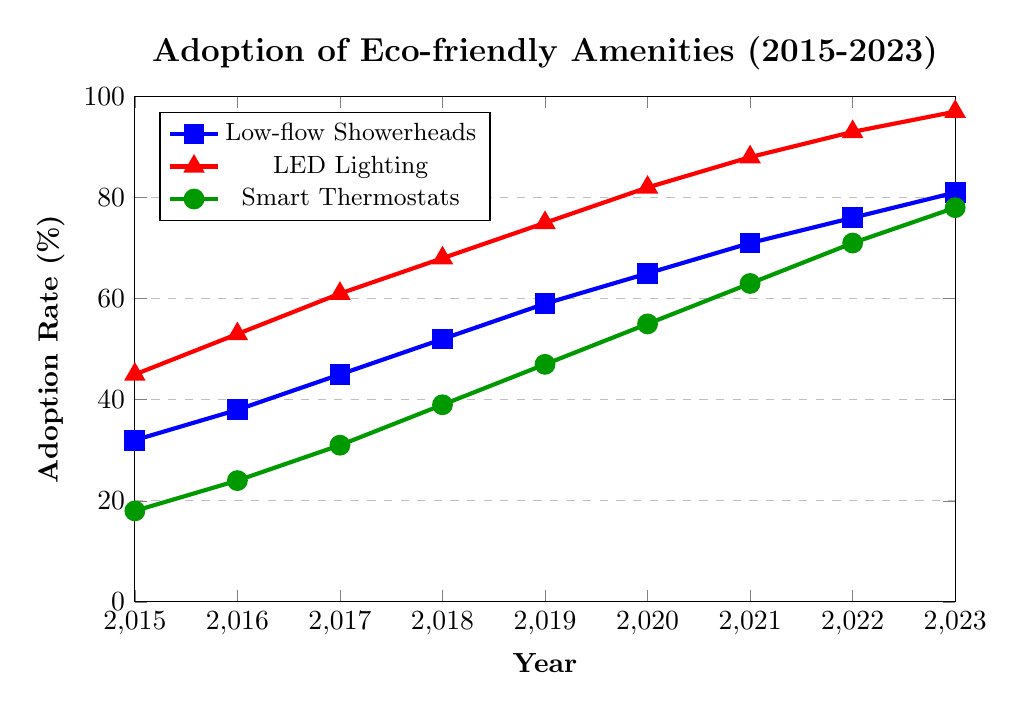What year did low-flow showerheads surpass a 50% adoption rate? According to the figure, low-flow showerheads passed the 50% adoption rate in 2018. This is observed by following the blue line until it crosses the 50% mark.
Answer: 2018 Which amenity had the highest adoption rate in 2023? By looking at the heights of the lines in 2023, the red line representing LED lighting reaches the highest point, indicating it had the highest adoption rate.
Answer: LED lighting How much did the adoption rate of smart thermostats increase from 2015 to 2023? The adoption rate for smart thermostats was 18% in 2015 and 78% in 2023. The increase is calculated by subtracting the 2015 value from the 2023 value (78% - 18% = 60%).
Answer: 60% By how much did the adoption rate of LED lighting increase in the year 2023 compared to 2022? The adoption rate of LED lighting was 93% in 2022 and 97% in 2023. The increase is obtained by subtracting the 2022 value from the 2023 value (97% - 93% = 4%).
Answer: 4% Which year saw the highest year-over-year increase in the adoption rate of low-flow showerheads? To determine the highest year-over-year increase, you compare the increase between each consecutive year. By observing the differences between consecutive years for low-flow showerheads: 2015-2016 (6), 2016-2017 (7), 2017-2018 (7), 2018-2019 (7), 2019-2020 (6), 2020-2021 (6), 2021-2022 (5), 2022-2023 (5), the highest increase was seen from 2017 to 2018 and from 2016 to 2017 with an increase of 7%.
Answer: 2016 to 2017 and 2017 to 2018 What was the average adoption rate of smart thermostats over the given years? The adoption rates in the given years for smart thermostats are: 18%, 24%, 31%, 39%, 47%, 55%, 63%, 71%, and 78%. The average is calculated by summing these values and dividing by the number of years: (18 + 24 + 31 + 39 + 47 + 55 + 63 + 71 + 78) / 9 = 47.33%.
Answer: 47.33% Which two amenities had the closest adoption rates in 2021? In 2021, the adoption rates are 71% for low-flow showerheads, 88% for LED lighting, and 63% for smart thermostats. By comparing these values, the smallest difference is between low-flow showerheads (71%) and smart thermostats (63%), a difference of 8%.
Answer: Low-flow showerheads and smart thermostats By what percentage did the adoption rate of low-flow showerheads increase annually on average from 2015 to 2023? To find the average annual increase, you first calculate the total increase (81% - 32% = 49%) and then divide by the number of years (2023 - 2015 = 8 years). Thus, 49% / 8 years equals a 6.125% average annual increase.
Answer: 6.125% Did LED lighting always have a higher adoption rate than low-flow showerheads? Observing the graph, the red line (LED lighting) is always above the blue line (low-flow showerheads) for every year from 2015 to 2023, indicating that LED lighting had a higher adoption rate in all the given years.
Answer: Yes 